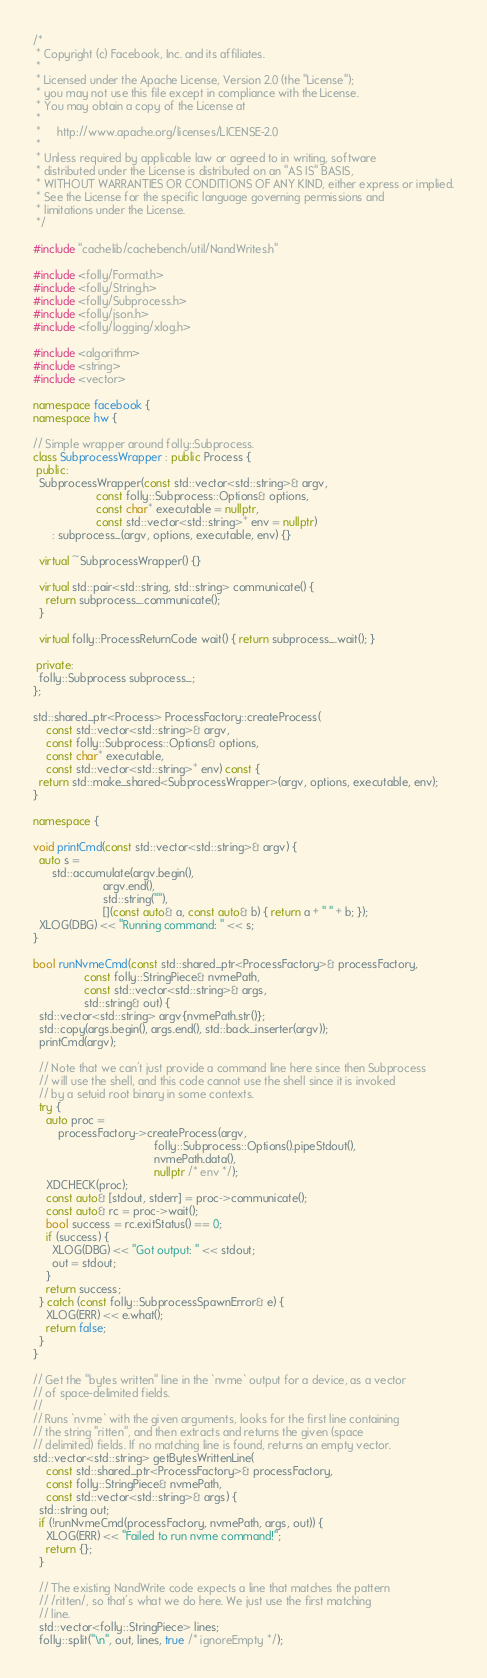<code> <loc_0><loc_0><loc_500><loc_500><_C++_>/*
 * Copyright (c) Facebook, Inc. and its affiliates.
 *
 * Licensed under the Apache License, Version 2.0 (the "License");
 * you may not use this file except in compliance with the License.
 * You may obtain a copy of the License at
 *
 *     http://www.apache.org/licenses/LICENSE-2.0
 *
 * Unless required by applicable law or agreed to in writing, software
 * distributed under the License is distributed on an "AS IS" BASIS,
 * WITHOUT WARRANTIES OR CONDITIONS OF ANY KIND, either express or implied.
 * See the License for the specific language governing permissions and
 * limitations under the License.
 */

#include "cachelib/cachebench/util/NandWrites.h"

#include <folly/Format.h>
#include <folly/String.h>
#include <folly/Subprocess.h>
#include <folly/json.h>
#include <folly/logging/xlog.h>

#include <algorithm>
#include <string>
#include <vector>

namespace facebook {
namespace hw {

// Simple wrapper around folly::Subprocess.
class SubprocessWrapper : public Process {
 public:
  SubprocessWrapper(const std::vector<std::string>& argv,
                    const folly::Subprocess::Options& options,
                    const char* executable = nullptr,
                    const std::vector<std::string>* env = nullptr)
      : subprocess_(argv, options, executable, env) {}

  virtual ~SubprocessWrapper() {}

  virtual std::pair<std::string, std::string> communicate() {
    return subprocess_.communicate();
  }

  virtual folly::ProcessReturnCode wait() { return subprocess_.wait(); }

 private:
  folly::Subprocess subprocess_;
};

std::shared_ptr<Process> ProcessFactory::createProcess(
    const std::vector<std::string>& argv,
    const folly::Subprocess::Options& options,
    const char* executable,
    const std::vector<std::string>* env) const {
  return std::make_shared<SubprocessWrapper>(argv, options, executable, env);
}

namespace {

void printCmd(const std::vector<std::string>& argv) {
  auto s =
      std::accumulate(argv.begin(),
                      argv.end(),
                      std::string(""),
                      [](const auto& a, const auto& b) { return a + " " + b; });
  XLOG(DBG) << "Running command: " << s;
}

bool runNvmeCmd(const std::shared_ptr<ProcessFactory>& processFactory,
                const folly::StringPiece& nvmePath,
                const std::vector<std::string>& args,
                std::string& out) {
  std::vector<std::string> argv{nvmePath.str()};
  std::copy(args.begin(), args.end(), std::back_inserter(argv));
  printCmd(argv);

  // Note that we can't just provide a command line here since then Subprocess
  // will use the shell, and this code cannot use the shell since it is invoked
  // by a setuid root binary in some contexts.
  try {
    auto proc =
        processFactory->createProcess(argv,
                                      folly::Subprocess::Options().pipeStdout(),
                                      nvmePath.data(),
                                      nullptr /* env */);
    XDCHECK(proc);
    const auto& [stdout, stderr] = proc->communicate();
    const auto& rc = proc->wait();
    bool success = rc.exitStatus() == 0;
    if (success) {
      XLOG(DBG) << "Got output: " << stdout;
      out = stdout;
    }
    return success;
  } catch (const folly::SubprocessSpawnError& e) {
    XLOG(ERR) << e.what();
    return false;
  }
}

// Get the "bytes written" line in the `nvme` output for a device, as a vector
// of space-delimited fields.
//
// Runs `nvme` with the given arguments, looks for the first line containing
// the string "ritten", and then extracts and returns the given (space
// delimited) fields. If no matching line is found, returns an empty vector.
std::vector<std::string> getBytesWrittenLine(
    const std::shared_ptr<ProcessFactory>& processFactory,
    const folly::StringPiece& nvmePath,
    const std::vector<std::string>& args) {
  std::string out;
  if (!runNvmeCmd(processFactory, nvmePath, args, out)) {
    XLOG(ERR) << "Failed to run nvme command!";
    return {};
  }

  // The existing NandWrite code expects a line that matches the pattern
  // /ritten/, so that's what we do here. We just use the first matching
  // line.
  std::vector<folly::StringPiece> lines;
  folly::split("\n", out, lines, true /* ignoreEmpty */);</code> 